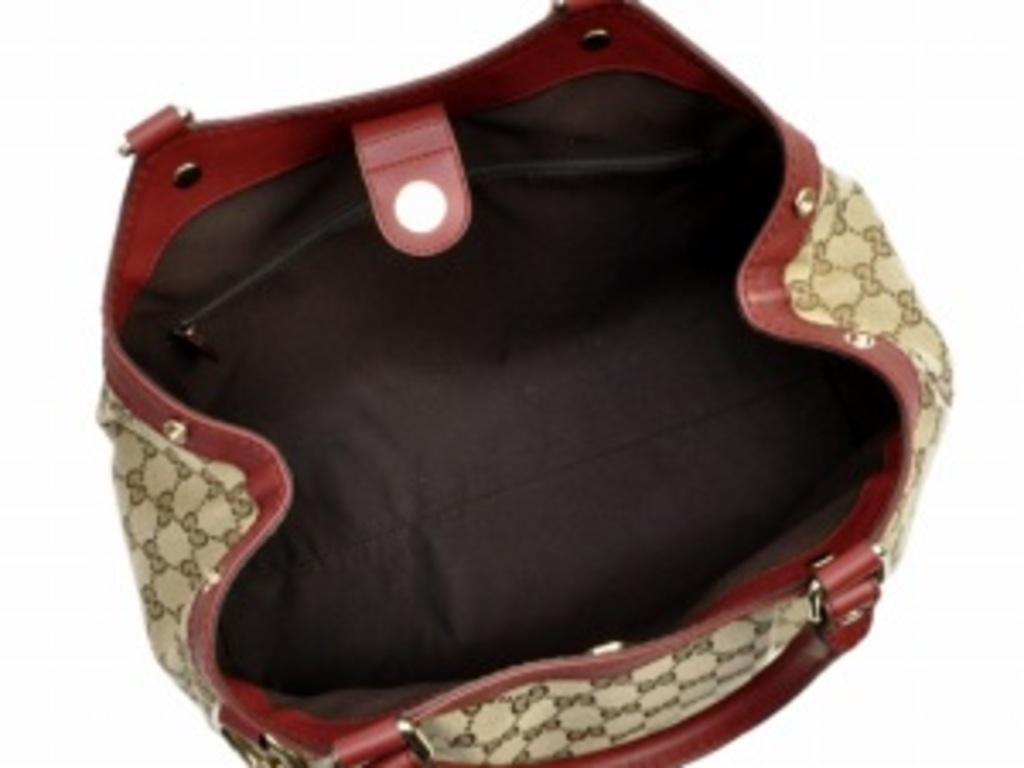What object is visible in the image that can hold items? There is a bag in the image that can hold items. What is the current state of the bag in the image? The bag is opened in the image. What type of items can be seen inside the bag? There are screws in the bag. How can the bag be carried or moved? There is a handle associated with the bag. How many dimes are visible in the image? There are no dimes present in the image. What type of pies are being baked in the image? There is no reference to pies or baking in the image. 